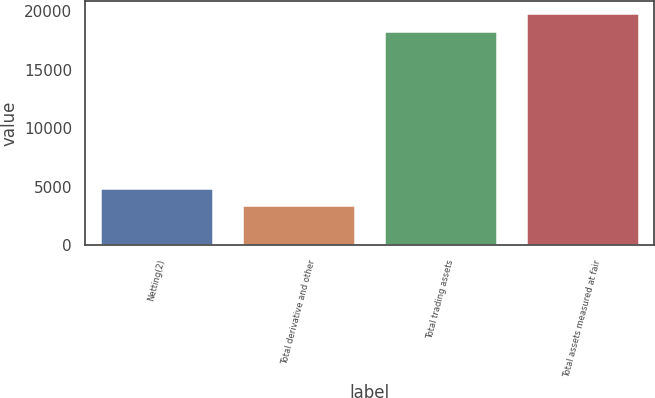<chart> <loc_0><loc_0><loc_500><loc_500><bar_chart><fcel>Netting(2)<fcel>Total derivative and other<fcel>Total trading assets<fcel>Total assets measured at fair<nl><fcel>4931<fcel>3425<fcel>18344<fcel>19836.7<nl></chart> 